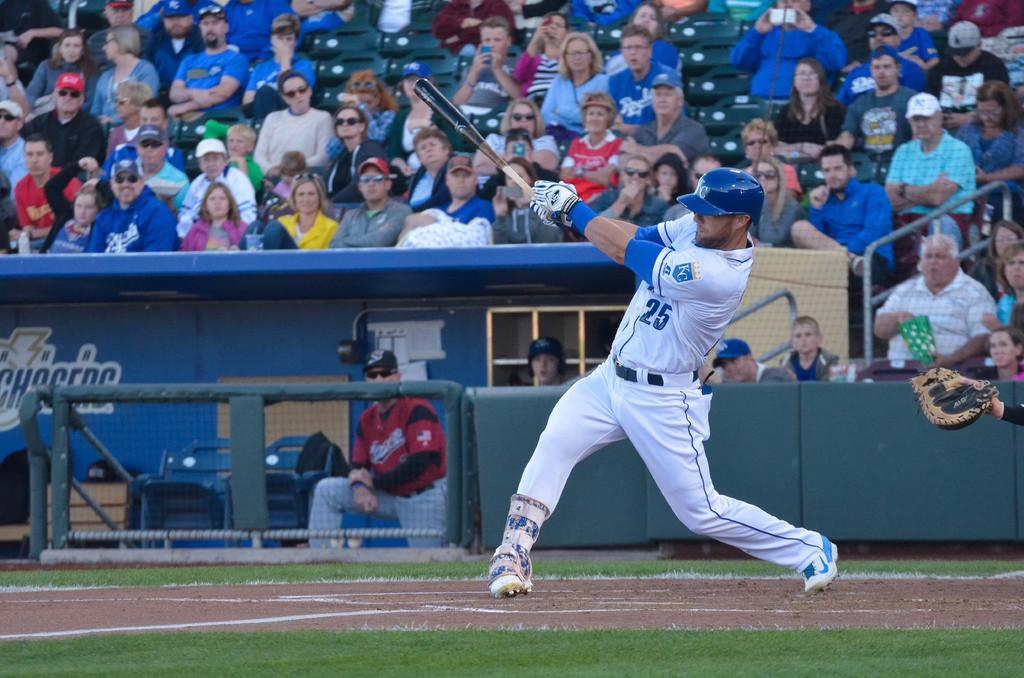<image>
Describe the image concisely. a baseball player in number 25 jersey after hitting a ball 